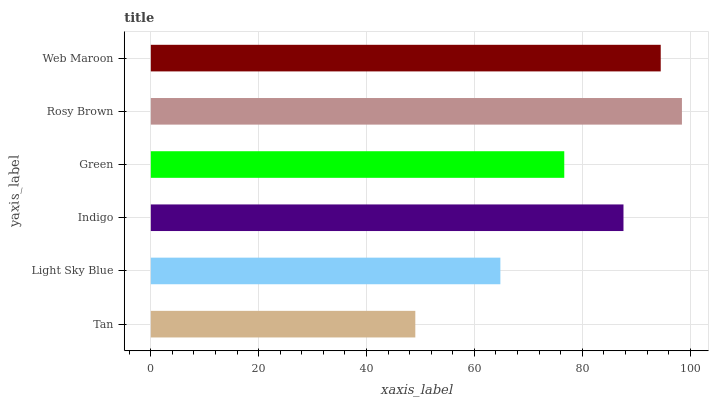Is Tan the minimum?
Answer yes or no. Yes. Is Rosy Brown the maximum?
Answer yes or no. Yes. Is Light Sky Blue the minimum?
Answer yes or no. No. Is Light Sky Blue the maximum?
Answer yes or no. No. Is Light Sky Blue greater than Tan?
Answer yes or no. Yes. Is Tan less than Light Sky Blue?
Answer yes or no. Yes. Is Tan greater than Light Sky Blue?
Answer yes or no. No. Is Light Sky Blue less than Tan?
Answer yes or no. No. Is Indigo the high median?
Answer yes or no. Yes. Is Green the low median?
Answer yes or no. Yes. Is Green the high median?
Answer yes or no. No. Is Light Sky Blue the low median?
Answer yes or no. No. 